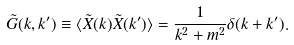Convert formula to latex. <formula><loc_0><loc_0><loc_500><loc_500>\tilde { G } ( k , k ^ { \prime } ) \equiv \langle \tilde { X } ( k ) \tilde { X } ( k ^ { \prime } ) \rangle = \frac { 1 } { k ^ { 2 } + m ^ { 2 } } \delta ( k + k ^ { \prime } ) .</formula> 